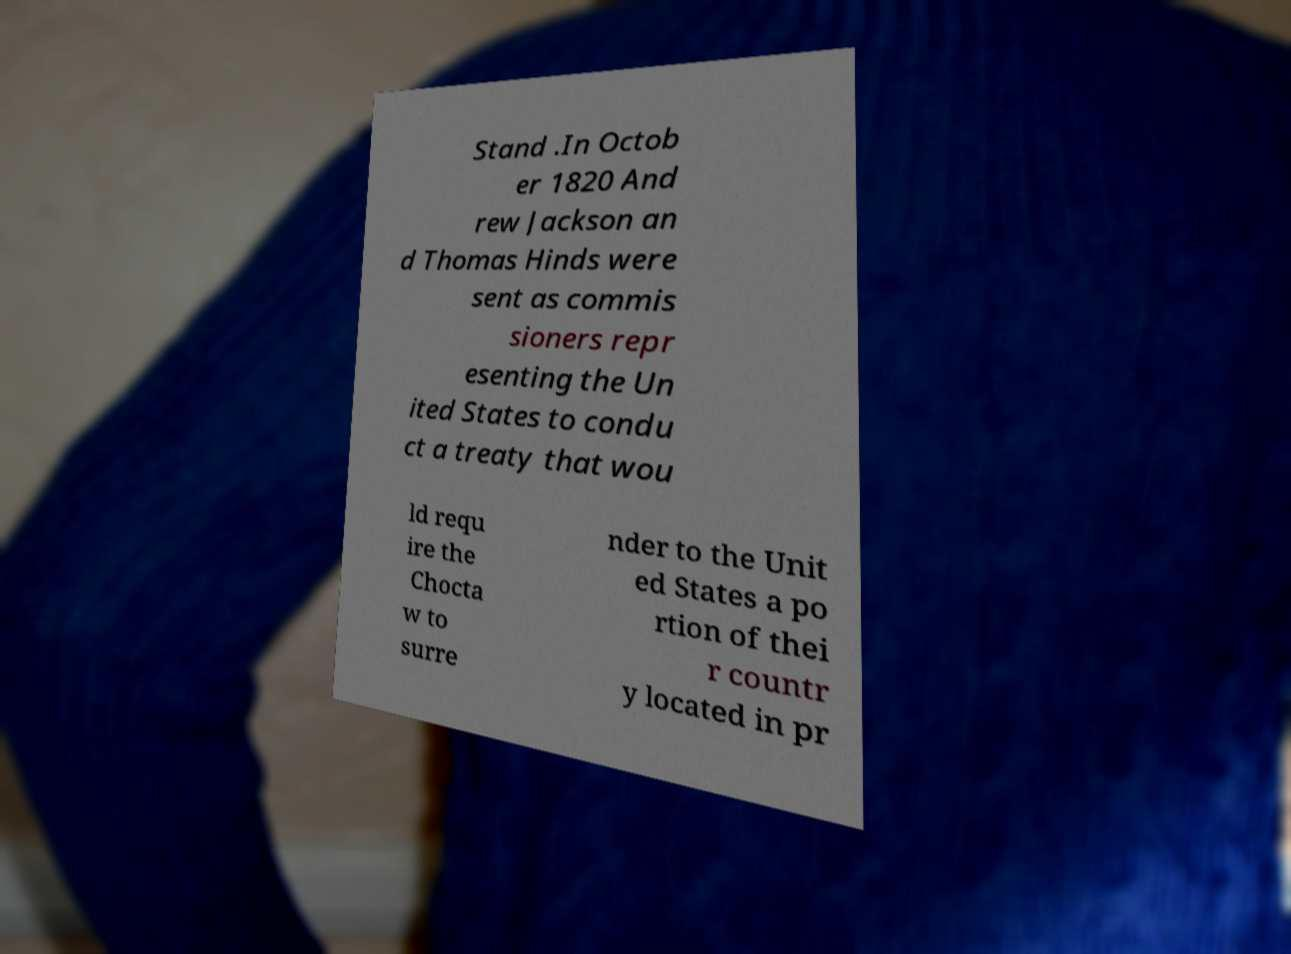Can you read and provide the text displayed in the image?This photo seems to have some interesting text. Can you extract and type it out for me? Stand .In Octob er 1820 And rew Jackson an d Thomas Hinds were sent as commis sioners repr esenting the Un ited States to condu ct a treaty that wou ld requ ire the Chocta w to surre nder to the Unit ed States a po rtion of thei r countr y located in pr 